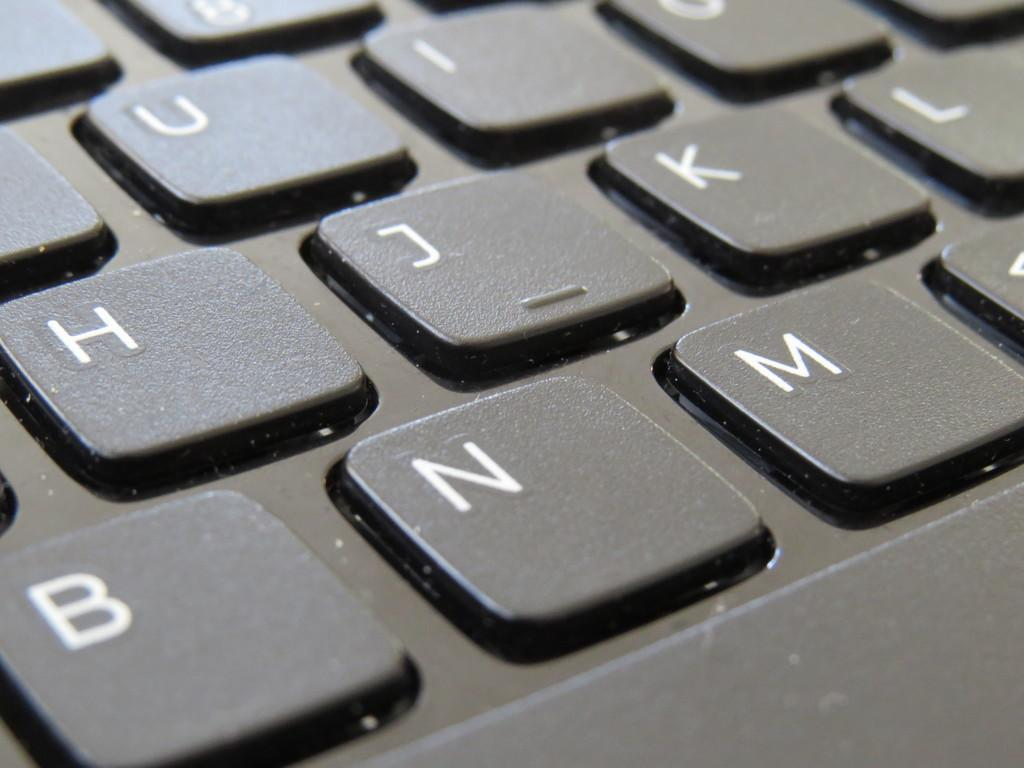<image>
Summarize the visual content of the image. A keyboard that uses the English alphabet and white text. 